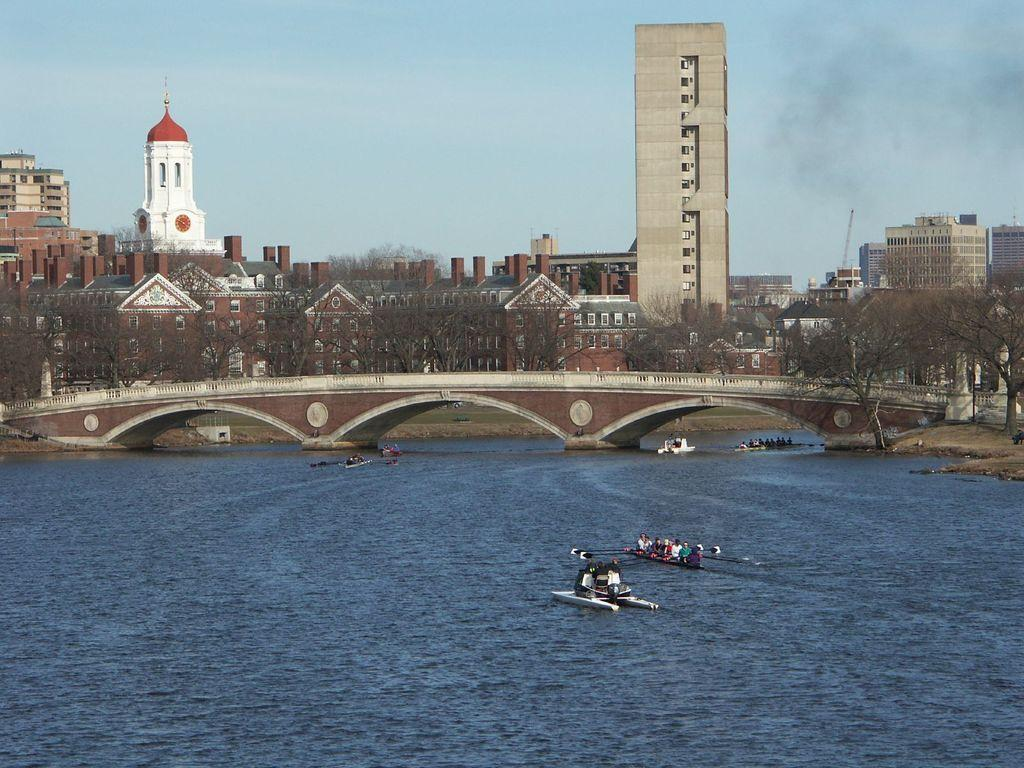What is happening on the water in the image? There are boats on the water in the image. Can you describe the people visible in the image? There are people visible in the image. What structure can be seen in the image? There is a bridge in the image. What can be seen in the background of the image? There are buildings, trees, and the sky visible in the background of the image. What type of event is the dad attending in the image? There is no dad or event present in the image. What show can be seen on the water in the image? There is no show present in the image; only boats on the water can be seen. 